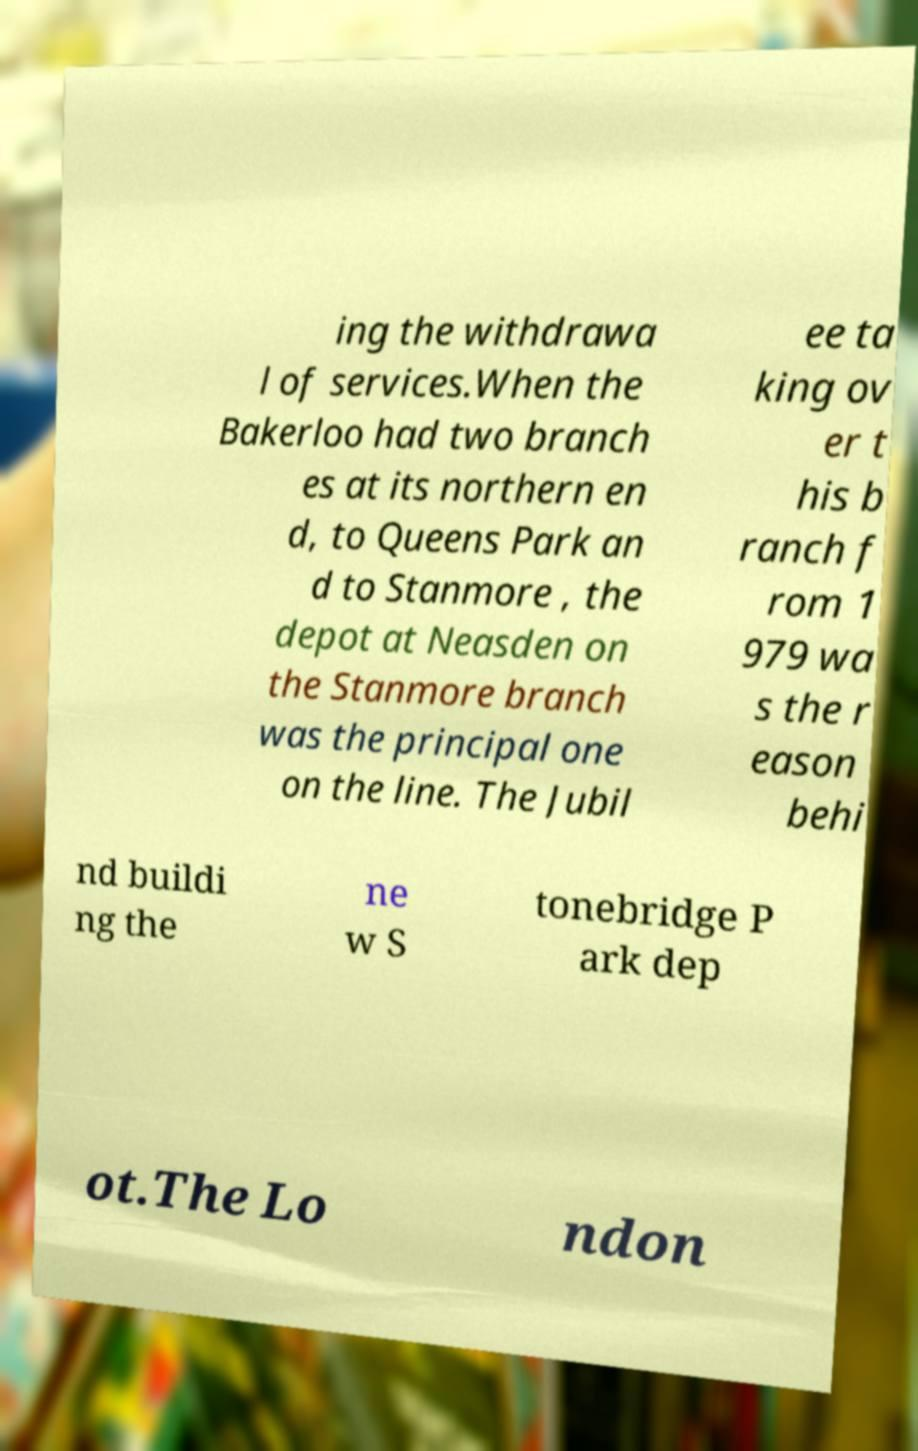Please read and relay the text visible in this image. What does it say? ing the withdrawa l of services.When the Bakerloo had two branch es at its northern en d, to Queens Park an d to Stanmore , the depot at Neasden on the Stanmore branch was the principal one on the line. The Jubil ee ta king ov er t his b ranch f rom 1 979 wa s the r eason behi nd buildi ng the ne w S tonebridge P ark dep ot.The Lo ndon 